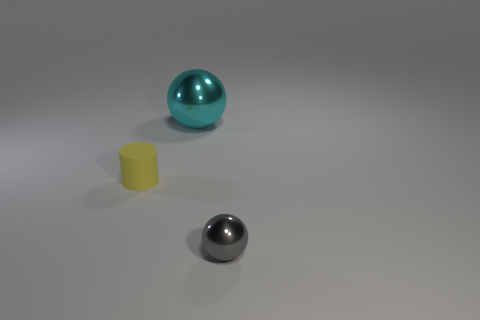Add 2 large objects. How many large objects are left? 3 Add 2 cyan metallic objects. How many cyan metallic objects exist? 3 Add 1 yellow matte things. How many objects exist? 4 Subtract all cyan balls. How many balls are left? 1 Subtract 0 red cylinders. How many objects are left? 3 Subtract all cylinders. How many objects are left? 2 Subtract 1 cylinders. How many cylinders are left? 0 Subtract all gray balls. Subtract all cyan blocks. How many balls are left? 1 Subtract all blue cylinders. How many purple spheres are left? 0 Subtract all big balls. Subtract all tiny blue cylinders. How many objects are left? 2 